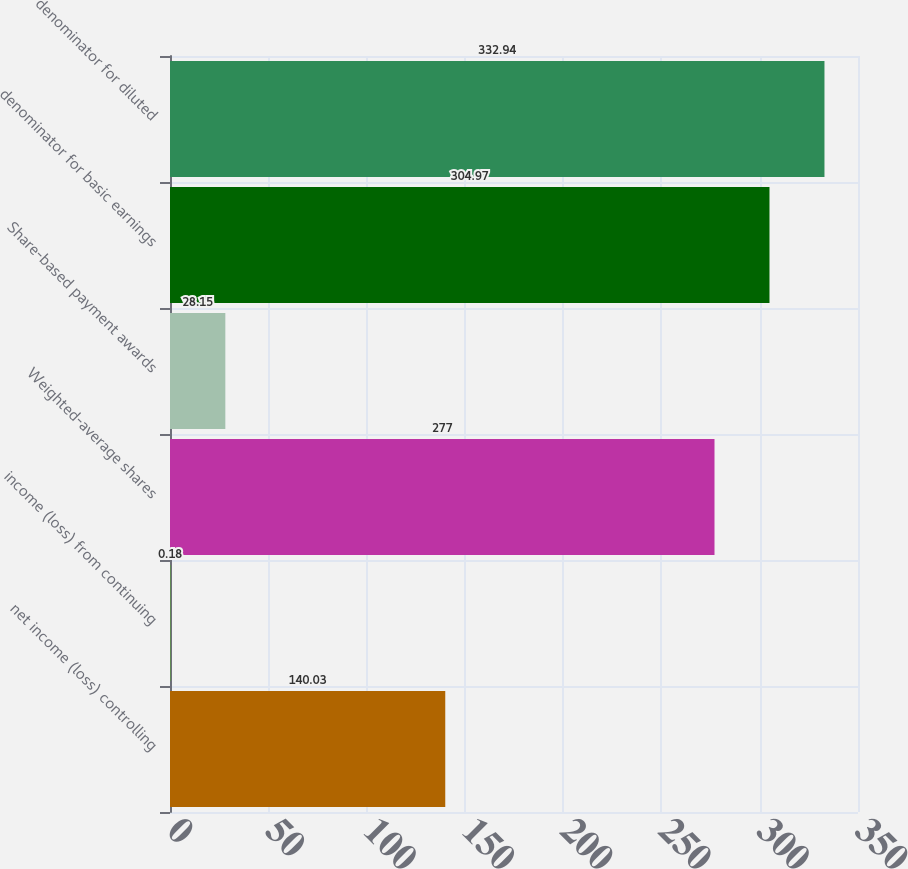<chart> <loc_0><loc_0><loc_500><loc_500><bar_chart><fcel>net income (loss) controlling<fcel>income (loss) from continuing<fcel>Weighted-average shares<fcel>Share-based payment awards<fcel>denominator for basic earnings<fcel>denominator for diluted<nl><fcel>140.03<fcel>0.18<fcel>277<fcel>28.15<fcel>304.97<fcel>332.94<nl></chart> 